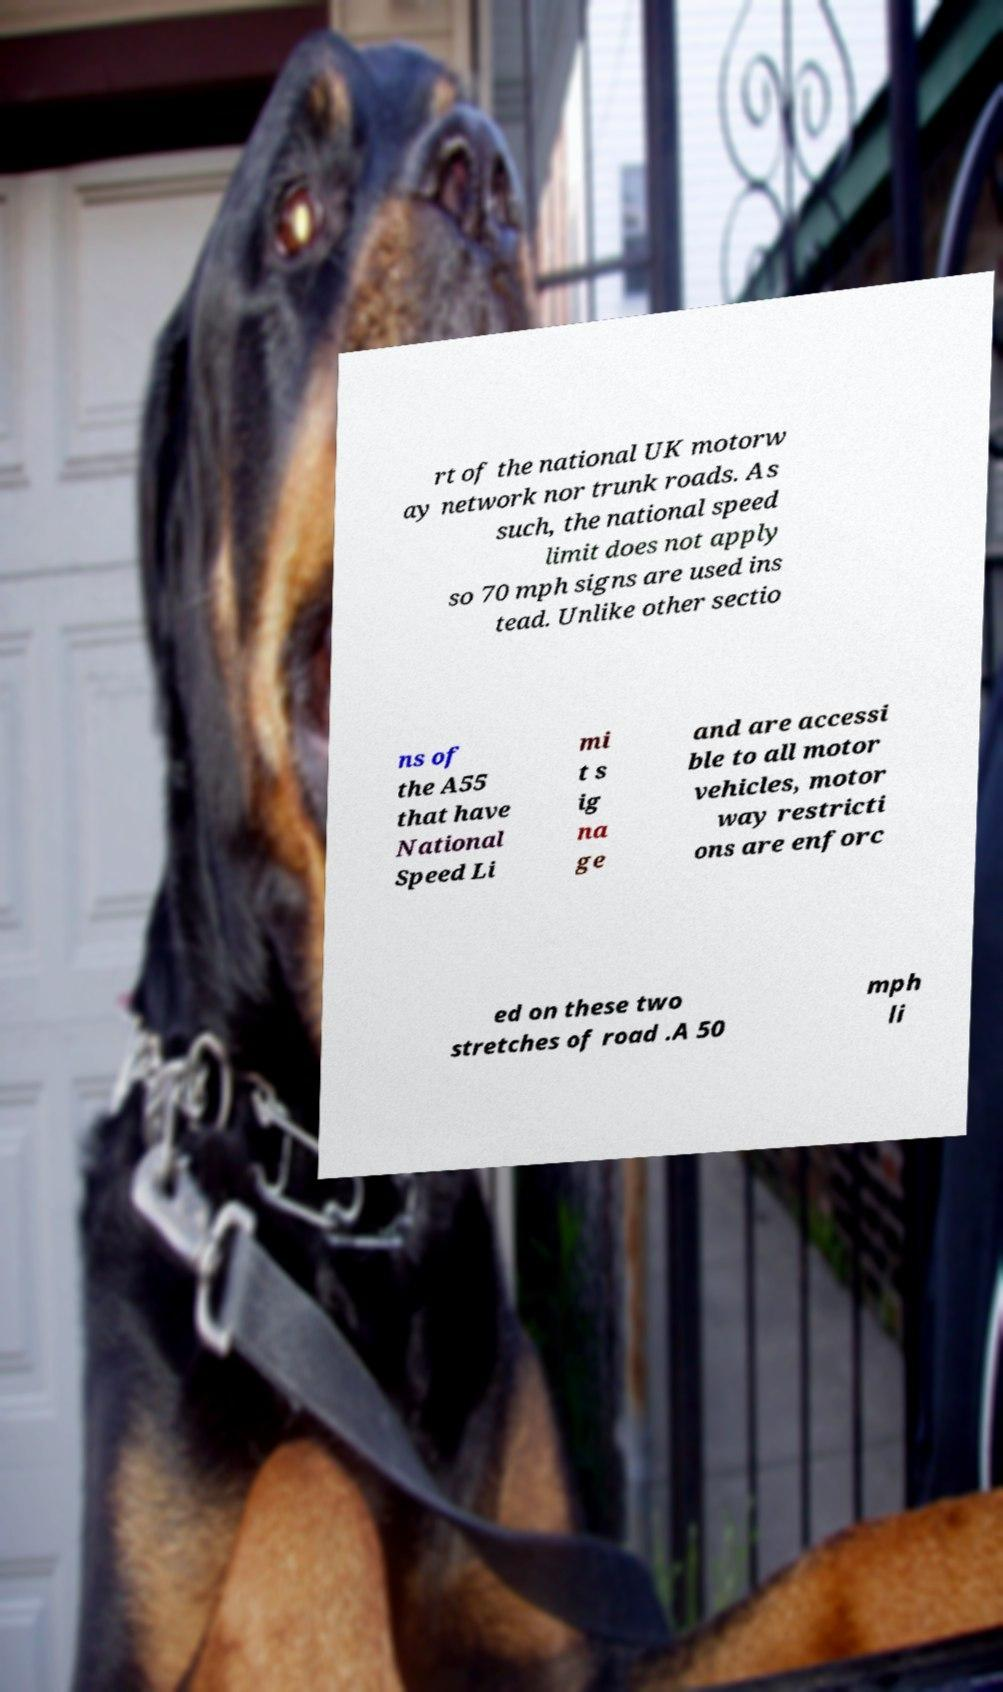There's text embedded in this image that I need extracted. Can you transcribe it verbatim? rt of the national UK motorw ay network nor trunk roads. As such, the national speed limit does not apply so 70 mph signs are used ins tead. Unlike other sectio ns of the A55 that have National Speed Li mi t s ig na ge and are accessi ble to all motor vehicles, motor way restricti ons are enforc ed on these two stretches of road .A 50 mph li 